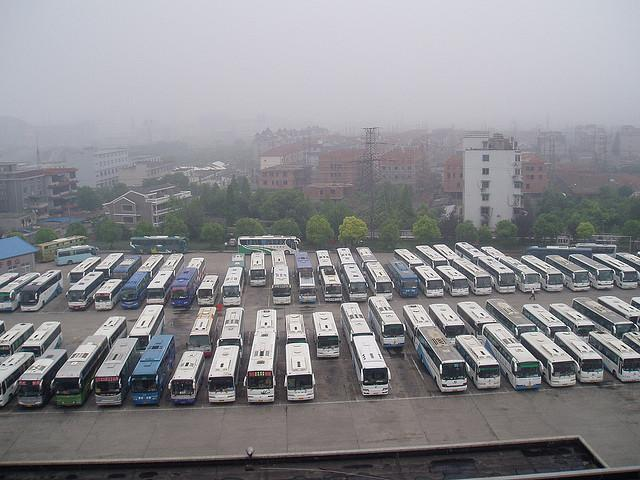What type of lot is this? Please explain your reasoning. bus depot. There are a lot of buses parked. 